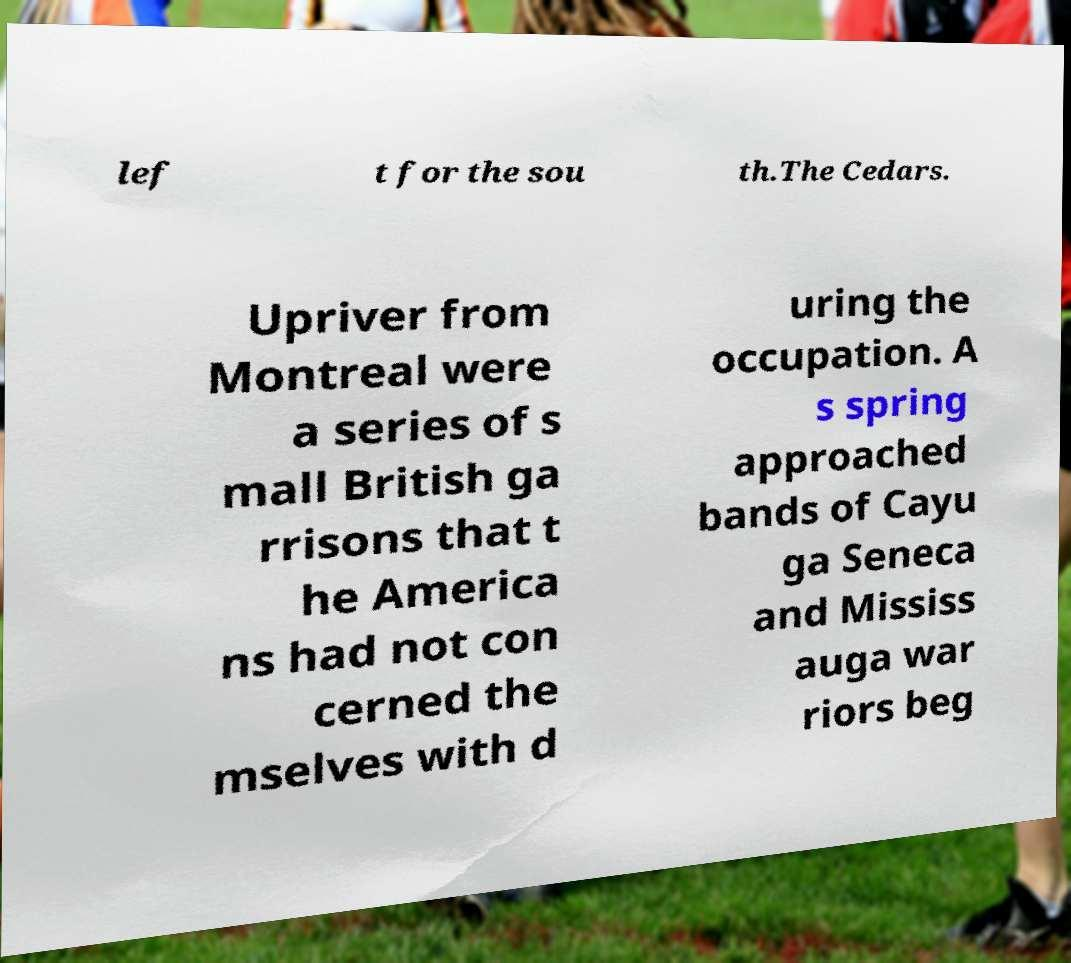Could you extract and type out the text from this image? lef t for the sou th.The Cedars. Upriver from Montreal were a series of s mall British ga rrisons that t he America ns had not con cerned the mselves with d uring the occupation. A s spring approached bands of Cayu ga Seneca and Mississ auga war riors beg 